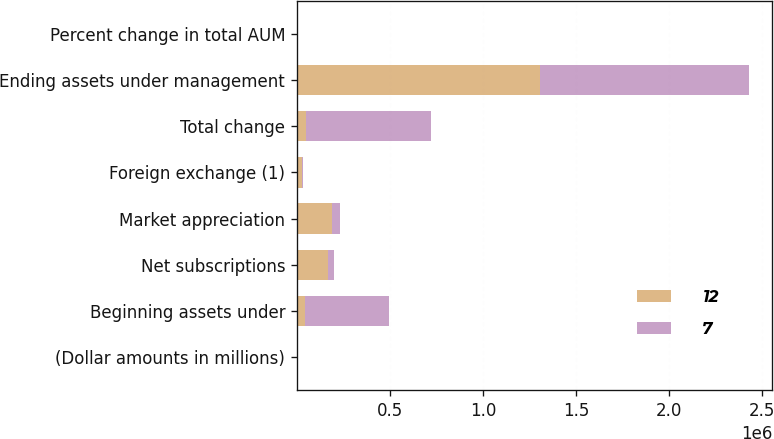<chart> <loc_0><loc_0><loc_500><loc_500><stacked_bar_chart><ecel><fcel>(Dollar amounts in millions)<fcel>Beginning assets under<fcel>Net subscriptions<fcel>Market appreciation<fcel>Foreign exchange (1)<fcel>Total change<fcel>Ending assets under management<fcel>Percent change in total AUM<nl><fcel>12<fcel>2008<fcel>42196<fcel>167604<fcel>188950<fcel>28147<fcel>49493<fcel>1.30715e+06<fcel>4<nl><fcel>7<fcel>2006<fcel>452682<fcel>32814<fcel>42196<fcel>7777<fcel>671945<fcel>1.12463e+06<fcel>148<nl></chart> 